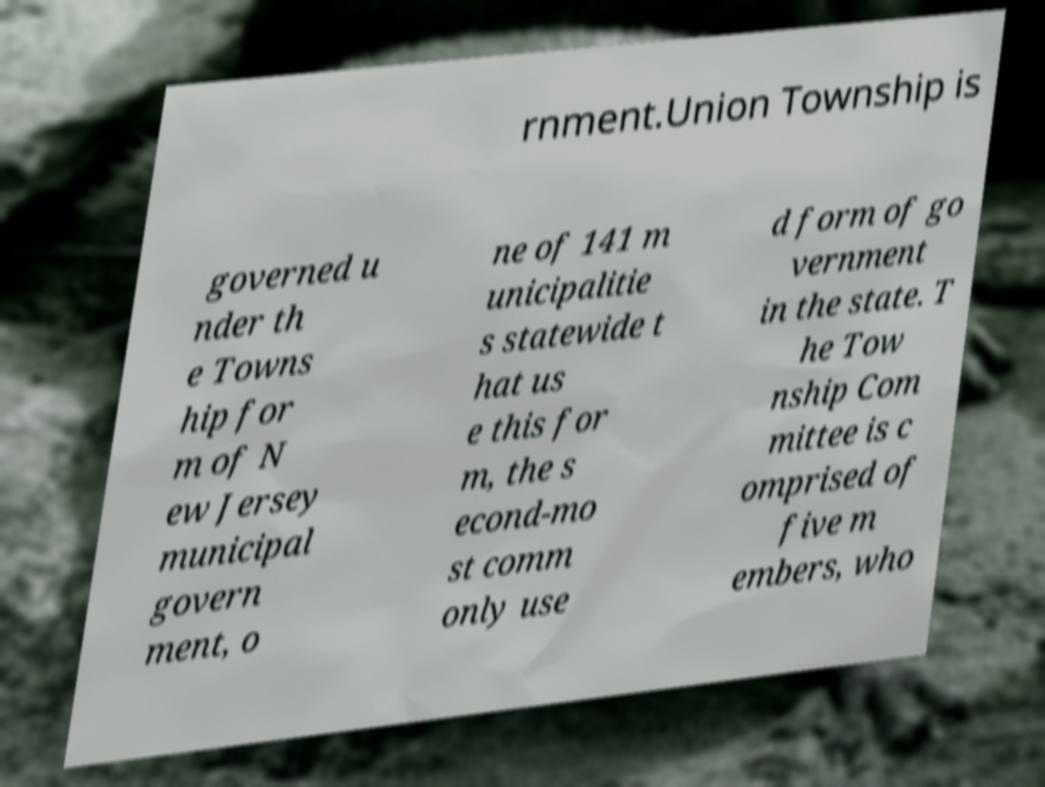There's text embedded in this image that I need extracted. Can you transcribe it verbatim? rnment.Union Township is governed u nder th e Towns hip for m of N ew Jersey municipal govern ment, o ne of 141 m unicipalitie s statewide t hat us e this for m, the s econd-mo st comm only use d form of go vernment in the state. T he Tow nship Com mittee is c omprised of five m embers, who 